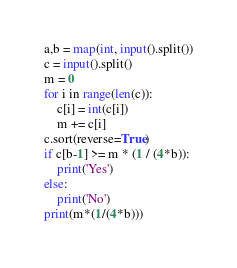Convert code to text. <code><loc_0><loc_0><loc_500><loc_500><_Python_>a,b = map(int, input().split())
c = input().split()
m = 0
for i in range(len(c)):
    c[i] = int(c[i])
    m += c[i]
c.sort(reverse=True)
if c[b-1] >= m * (1 / (4*b)):
    print('Yes')
else:
    print('No')
print(m*(1/(4*b)))</code> 